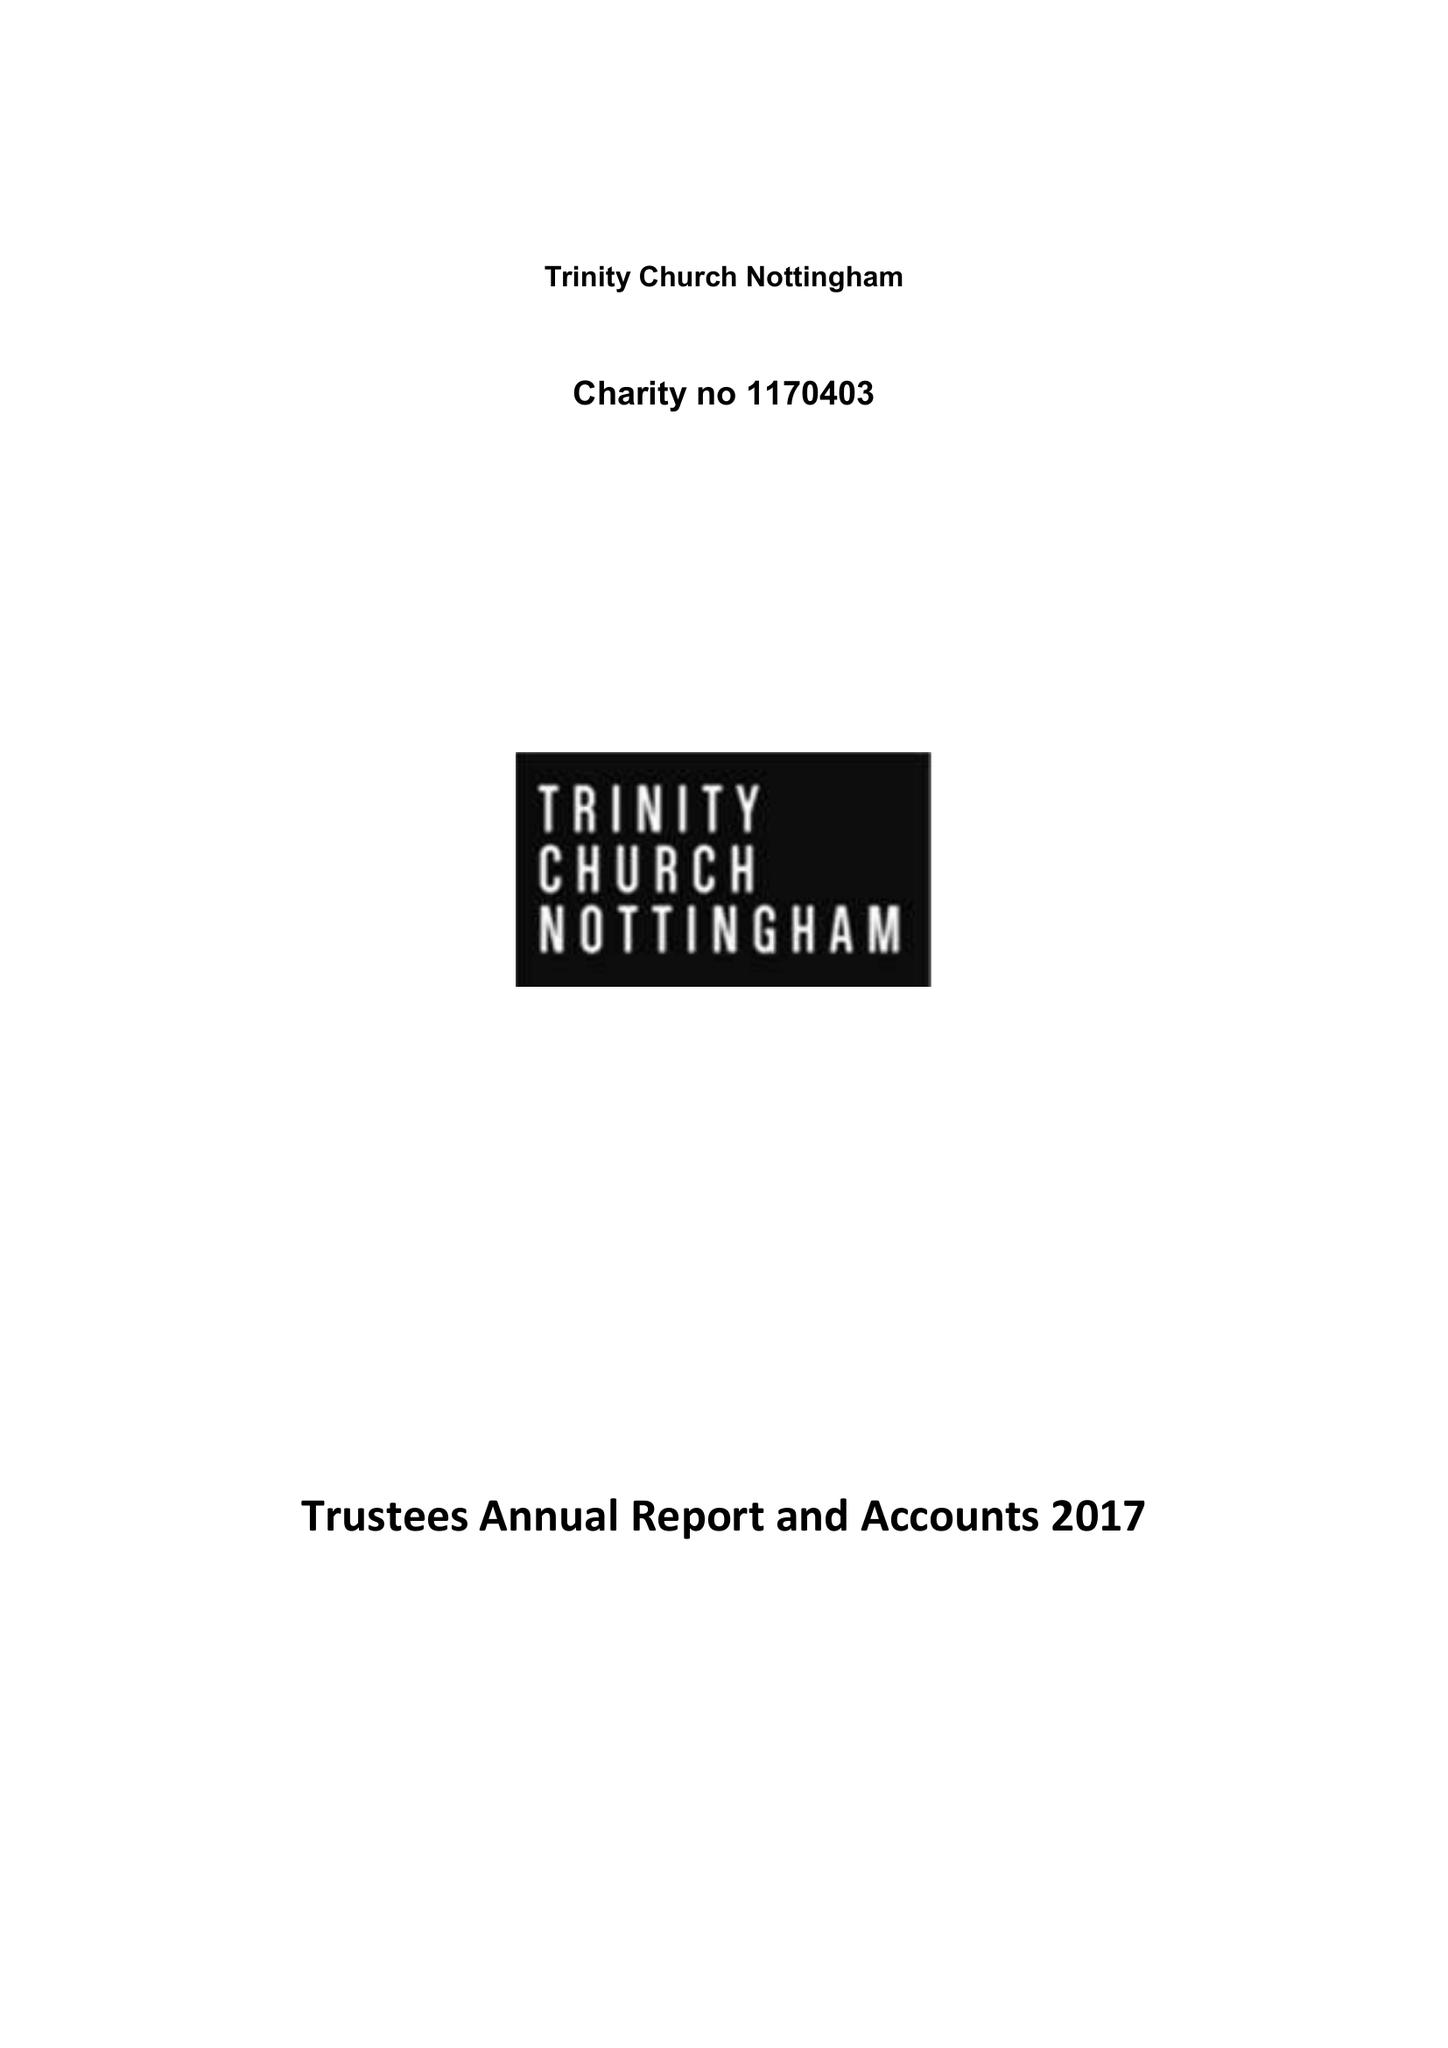What is the value for the address__street_line?
Answer the question using a single word or phrase. 192-194 MANSFIELD ROAD 